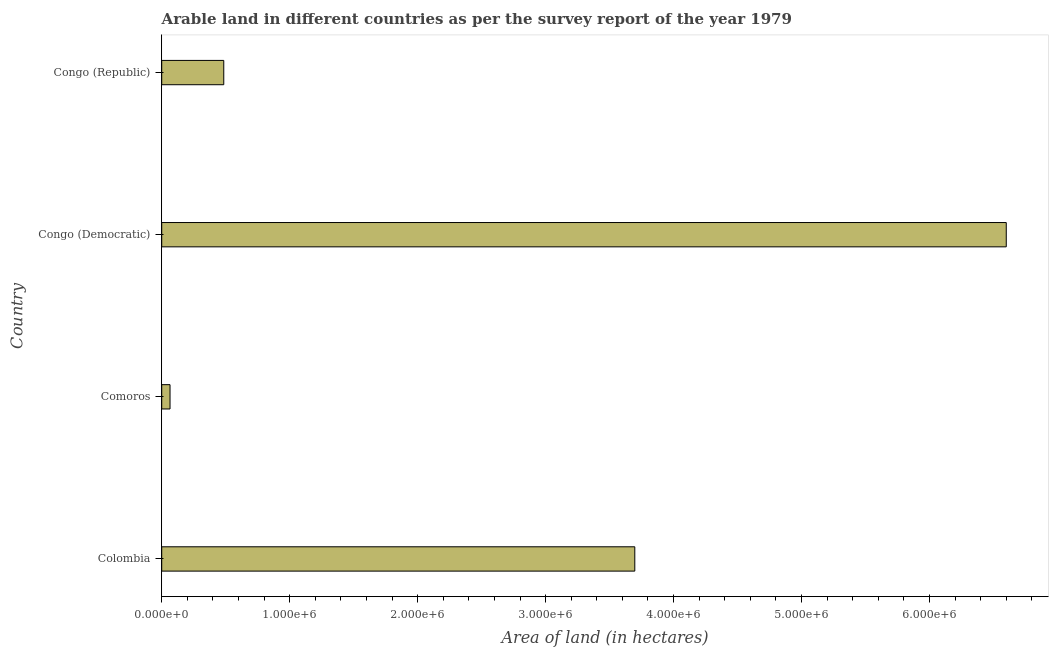Does the graph contain any zero values?
Provide a short and direct response. No. What is the title of the graph?
Keep it short and to the point. Arable land in different countries as per the survey report of the year 1979. What is the label or title of the X-axis?
Keep it short and to the point. Area of land (in hectares). What is the area of land in Congo (Republic)?
Make the answer very short. 4.85e+05. Across all countries, what is the maximum area of land?
Ensure brevity in your answer.  6.60e+06. Across all countries, what is the minimum area of land?
Your answer should be very brief. 6.50e+04. In which country was the area of land maximum?
Make the answer very short. Congo (Democratic). In which country was the area of land minimum?
Ensure brevity in your answer.  Comoros. What is the sum of the area of land?
Your response must be concise. 1.08e+07. What is the difference between the area of land in Comoros and Congo (Republic)?
Offer a terse response. -4.20e+05. What is the average area of land per country?
Ensure brevity in your answer.  2.71e+06. What is the median area of land?
Keep it short and to the point. 2.09e+06. What is the ratio of the area of land in Comoros to that in Congo (Republic)?
Your answer should be compact. 0.13. Is the area of land in Comoros less than that in Congo (Democratic)?
Keep it short and to the point. Yes. What is the difference between the highest and the second highest area of land?
Make the answer very short. 2.90e+06. What is the difference between the highest and the lowest area of land?
Provide a short and direct response. 6.54e+06. How many bars are there?
Keep it short and to the point. 4. How many countries are there in the graph?
Offer a terse response. 4. What is the Area of land (in hectares) in Colombia?
Your answer should be very brief. 3.70e+06. What is the Area of land (in hectares) in Comoros?
Offer a terse response. 6.50e+04. What is the Area of land (in hectares) of Congo (Democratic)?
Keep it short and to the point. 6.60e+06. What is the Area of land (in hectares) in Congo (Republic)?
Provide a short and direct response. 4.85e+05. What is the difference between the Area of land (in hectares) in Colombia and Comoros?
Your answer should be very brief. 3.63e+06. What is the difference between the Area of land (in hectares) in Colombia and Congo (Democratic)?
Provide a succinct answer. -2.90e+06. What is the difference between the Area of land (in hectares) in Colombia and Congo (Republic)?
Your answer should be compact. 3.21e+06. What is the difference between the Area of land (in hectares) in Comoros and Congo (Democratic)?
Provide a succinct answer. -6.54e+06. What is the difference between the Area of land (in hectares) in Comoros and Congo (Republic)?
Ensure brevity in your answer.  -4.20e+05. What is the difference between the Area of land (in hectares) in Congo (Democratic) and Congo (Republic)?
Give a very brief answer. 6.12e+06. What is the ratio of the Area of land (in hectares) in Colombia to that in Comoros?
Your response must be concise. 56.88. What is the ratio of the Area of land (in hectares) in Colombia to that in Congo (Democratic)?
Your answer should be compact. 0.56. What is the ratio of the Area of land (in hectares) in Colombia to that in Congo (Republic)?
Give a very brief answer. 7.62. What is the ratio of the Area of land (in hectares) in Comoros to that in Congo (Democratic)?
Offer a very short reply. 0.01. What is the ratio of the Area of land (in hectares) in Comoros to that in Congo (Republic)?
Provide a short and direct response. 0.13. What is the ratio of the Area of land (in hectares) in Congo (Democratic) to that in Congo (Republic)?
Keep it short and to the point. 13.61. 